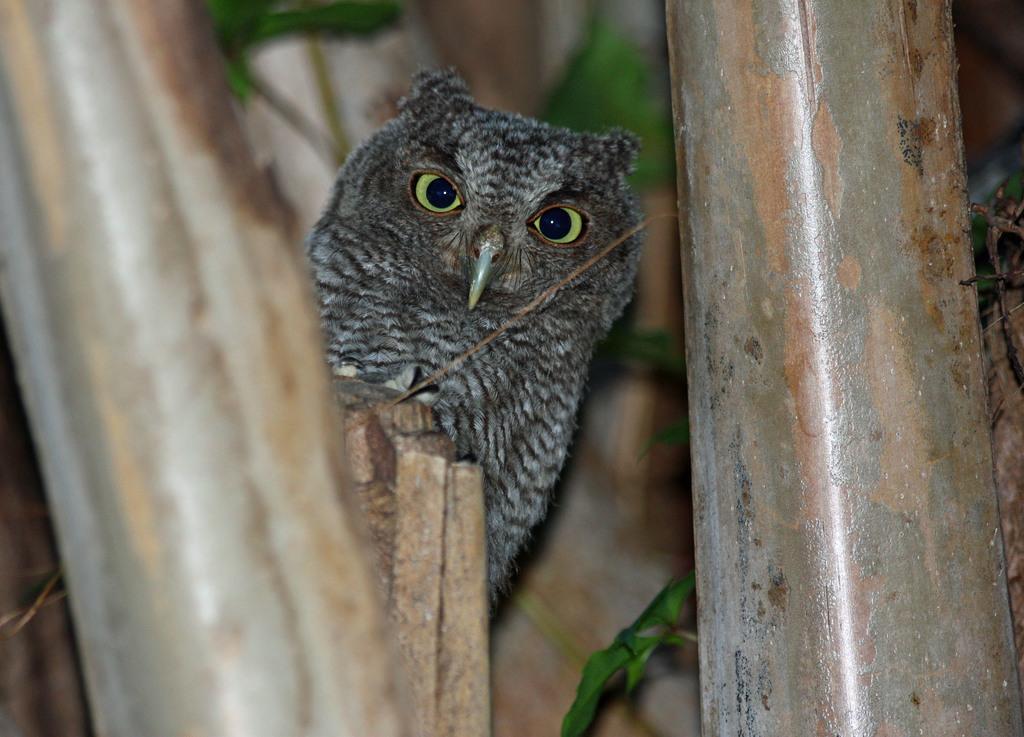In one or two sentences, can you explain what this image depicts? In this image we can see an owl, leaves and also the iron rods. 